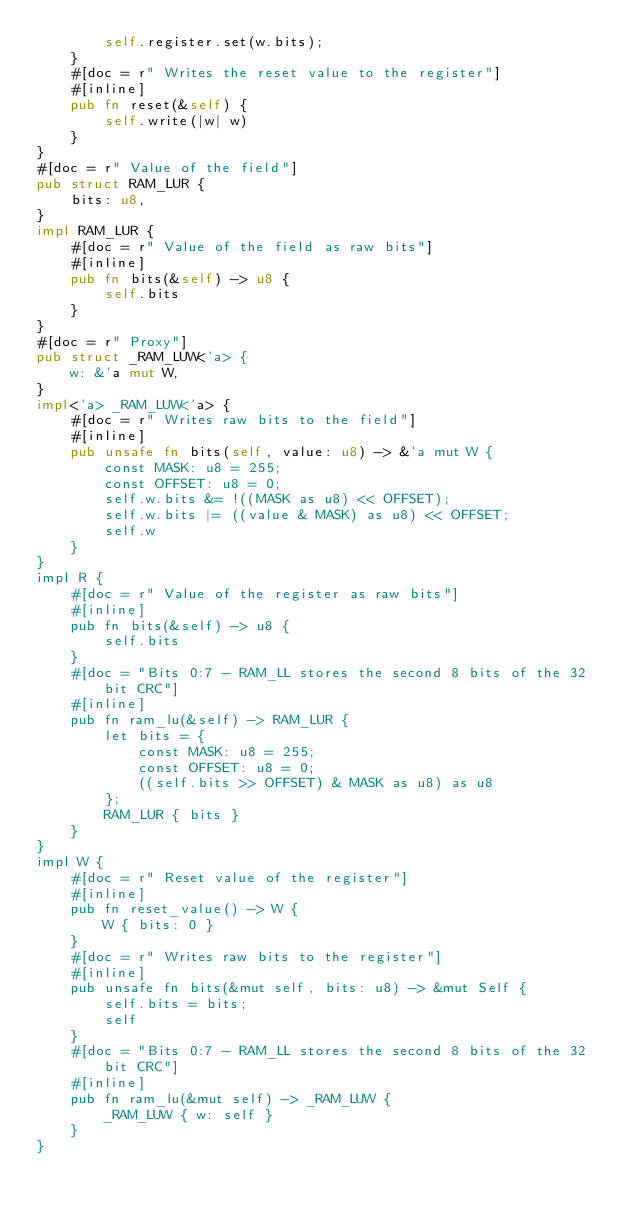<code> <loc_0><loc_0><loc_500><loc_500><_Rust_>        self.register.set(w.bits);
    }
    #[doc = r" Writes the reset value to the register"]
    #[inline]
    pub fn reset(&self) {
        self.write(|w| w)
    }
}
#[doc = r" Value of the field"]
pub struct RAM_LUR {
    bits: u8,
}
impl RAM_LUR {
    #[doc = r" Value of the field as raw bits"]
    #[inline]
    pub fn bits(&self) -> u8 {
        self.bits
    }
}
#[doc = r" Proxy"]
pub struct _RAM_LUW<'a> {
    w: &'a mut W,
}
impl<'a> _RAM_LUW<'a> {
    #[doc = r" Writes raw bits to the field"]
    #[inline]
    pub unsafe fn bits(self, value: u8) -> &'a mut W {
        const MASK: u8 = 255;
        const OFFSET: u8 = 0;
        self.w.bits &= !((MASK as u8) << OFFSET);
        self.w.bits |= ((value & MASK) as u8) << OFFSET;
        self.w
    }
}
impl R {
    #[doc = r" Value of the register as raw bits"]
    #[inline]
    pub fn bits(&self) -> u8 {
        self.bits
    }
    #[doc = "Bits 0:7 - RAM_LL stores the second 8 bits of the 32 bit CRC"]
    #[inline]
    pub fn ram_lu(&self) -> RAM_LUR {
        let bits = {
            const MASK: u8 = 255;
            const OFFSET: u8 = 0;
            ((self.bits >> OFFSET) & MASK as u8) as u8
        };
        RAM_LUR { bits }
    }
}
impl W {
    #[doc = r" Reset value of the register"]
    #[inline]
    pub fn reset_value() -> W {
        W { bits: 0 }
    }
    #[doc = r" Writes raw bits to the register"]
    #[inline]
    pub unsafe fn bits(&mut self, bits: u8) -> &mut Self {
        self.bits = bits;
        self
    }
    #[doc = "Bits 0:7 - RAM_LL stores the second 8 bits of the 32 bit CRC"]
    #[inline]
    pub fn ram_lu(&mut self) -> _RAM_LUW {
        _RAM_LUW { w: self }
    }
}
</code> 